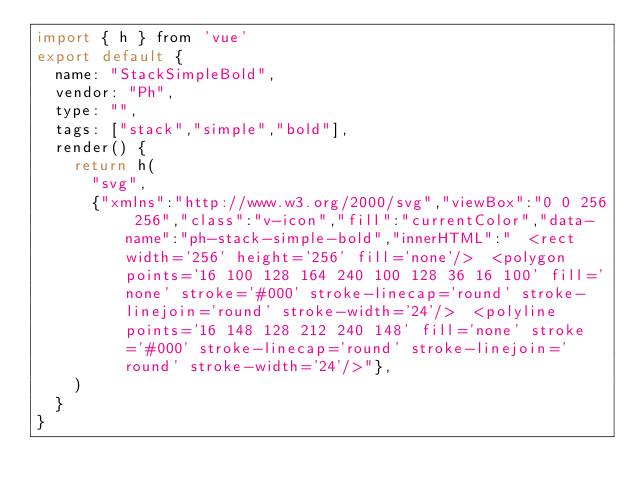<code> <loc_0><loc_0><loc_500><loc_500><_JavaScript_>import { h } from 'vue'
export default {
  name: "StackSimpleBold",
  vendor: "Ph",
  type: "",
  tags: ["stack","simple","bold"],
  render() {
    return h(
      "svg",
      {"xmlns":"http://www.w3.org/2000/svg","viewBox":"0 0 256 256","class":"v-icon","fill":"currentColor","data-name":"ph-stack-simple-bold","innerHTML":"  <rect width='256' height='256' fill='none'/>  <polygon points='16 100 128 164 240 100 128 36 16 100' fill='none' stroke='#000' stroke-linecap='round' stroke-linejoin='round' stroke-width='24'/>  <polyline points='16 148 128 212 240 148' fill='none' stroke='#000' stroke-linecap='round' stroke-linejoin='round' stroke-width='24'/>"},
    )
  }
}</code> 